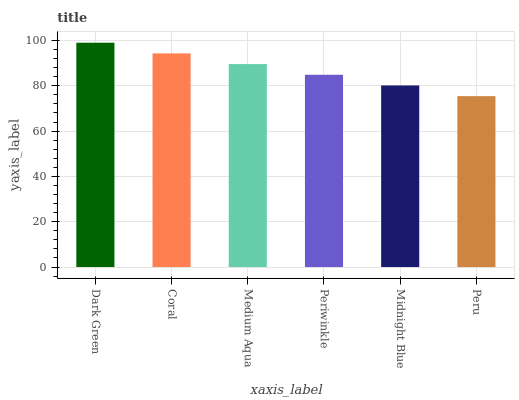Is Peru the minimum?
Answer yes or no. Yes. Is Dark Green the maximum?
Answer yes or no. Yes. Is Coral the minimum?
Answer yes or no. No. Is Coral the maximum?
Answer yes or no. No. Is Dark Green greater than Coral?
Answer yes or no. Yes. Is Coral less than Dark Green?
Answer yes or no. Yes. Is Coral greater than Dark Green?
Answer yes or no. No. Is Dark Green less than Coral?
Answer yes or no. No. Is Medium Aqua the high median?
Answer yes or no. Yes. Is Periwinkle the low median?
Answer yes or no. Yes. Is Dark Green the high median?
Answer yes or no. No. Is Medium Aqua the low median?
Answer yes or no. No. 